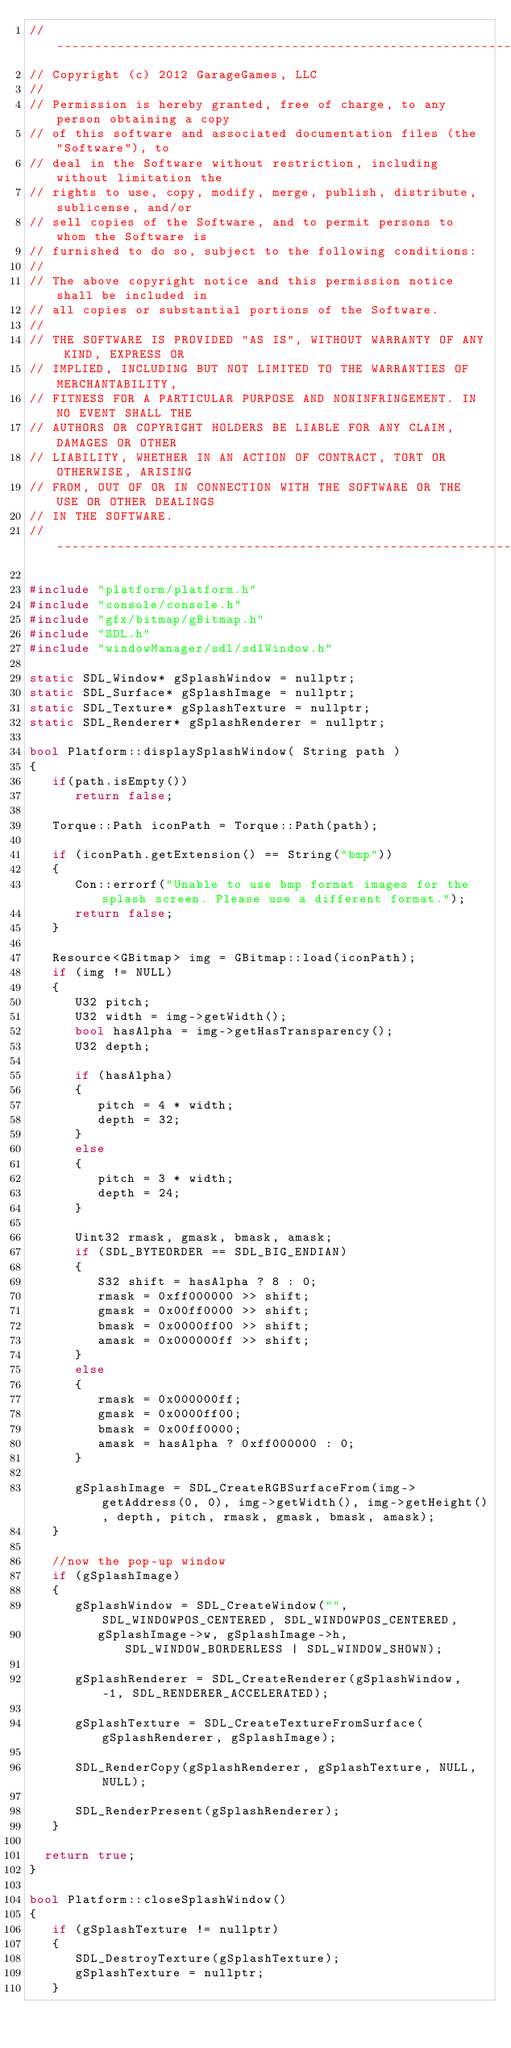<code> <loc_0><loc_0><loc_500><loc_500><_C++_>//-----------------------------------------------------------------------------
// Copyright (c) 2012 GarageGames, LLC
//
// Permission is hereby granted, free of charge, to any person obtaining a copy
// of this software and associated documentation files (the "Software"), to
// deal in the Software without restriction, including without limitation the
// rights to use, copy, modify, merge, publish, distribute, sublicense, and/or
// sell copies of the Software, and to permit persons to whom the Software is
// furnished to do so, subject to the following conditions:
//
// The above copyright notice and this permission notice shall be included in
// all copies or substantial portions of the Software.
//
// THE SOFTWARE IS PROVIDED "AS IS", WITHOUT WARRANTY OF ANY KIND, EXPRESS OR
// IMPLIED, INCLUDING BUT NOT LIMITED TO THE WARRANTIES OF MERCHANTABILITY,
// FITNESS FOR A PARTICULAR PURPOSE AND NONINFRINGEMENT. IN NO EVENT SHALL THE
// AUTHORS OR COPYRIGHT HOLDERS BE LIABLE FOR ANY CLAIM, DAMAGES OR OTHER
// LIABILITY, WHETHER IN AN ACTION OF CONTRACT, TORT OR OTHERWISE, ARISING
// FROM, OUT OF OR IN CONNECTION WITH THE SOFTWARE OR THE USE OR OTHER DEALINGS
// IN THE SOFTWARE.
//-----------------------------------------------------------------------------

#include "platform/platform.h"
#include "console/console.h"
#include "gfx/bitmap/gBitmap.h"
#include "SDL.h"
#include "windowManager/sdl/sdlWindow.h"

static SDL_Window* gSplashWindow = nullptr;
static SDL_Surface* gSplashImage = nullptr;
static SDL_Texture* gSplashTexture = nullptr;
static SDL_Renderer* gSplashRenderer = nullptr;

bool Platform::displaySplashWindow( String path )
{
   if(path.isEmpty())
      return false;

   Torque::Path iconPath = Torque::Path(path);

   if (iconPath.getExtension() == String("bmp"))
   {
      Con::errorf("Unable to use bmp format images for the splash screen. Please use a different format.");
      return false;
   }

   Resource<GBitmap> img = GBitmap::load(iconPath);
   if (img != NULL)
   {
      U32 pitch;
      U32 width = img->getWidth();
      bool hasAlpha = img->getHasTransparency();
      U32 depth;

      if (hasAlpha)
      {
         pitch = 4 * width;
         depth = 32;
      }
      else
      {
         pitch = 3 * width;
         depth = 24;
      }

      Uint32 rmask, gmask, bmask, amask;
      if (SDL_BYTEORDER == SDL_BIG_ENDIAN)
      {
         S32 shift = hasAlpha ? 8 : 0;
         rmask = 0xff000000 >> shift;
         gmask = 0x00ff0000 >> shift;
         bmask = 0x0000ff00 >> shift;
         amask = 0x000000ff >> shift;
      }
      else
      {
         rmask = 0x000000ff;
         gmask = 0x0000ff00;
         bmask = 0x00ff0000;
         amask = hasAlpha ? 0xff000000 : 0;
      }

      gSplashImage = SDL_CreateRGBSurfaceFrom(img->getAddress(0, 0), img->getWidth(), img->getHeight(), depth, pitch, rmask, gmask, bmask, amask);
   }

   //now the pop-up window
   if (gSplashImage)
   {
      gSplashWindow = SDL_CreateWindow("", SDL_WINDOWPOS_CENTERED, SDL_WINDOWPOS_CENTERED,
         gSplashImage->w, gSplashImage->h, SDL_WINDOW_BORDERLESS | SDL_WINDOW_SHOWN);

      gSplashRenderer = SDL_CreateRenderer(gSplashWindow, -1, SDL_RENDERER_ACCELERATED);

      gSplashTexture = SDL_CreateTextureFromSurface(gSplashRenderer, gSplashImage);

      SDL_RenderCopy(gSplashRenderer, gSplashTexture, NULL, NULL);

      SDL_RenderPresent(gSplashRenderer);
   }

	return true;
}

bool Platform::closeSplashWindow()
{
   if (gSplashTexture != nullptr)
   {
      SDL_DestroyTexture(gSplashTexture);
      gSplashTexture = nullptr;
   }</code> 